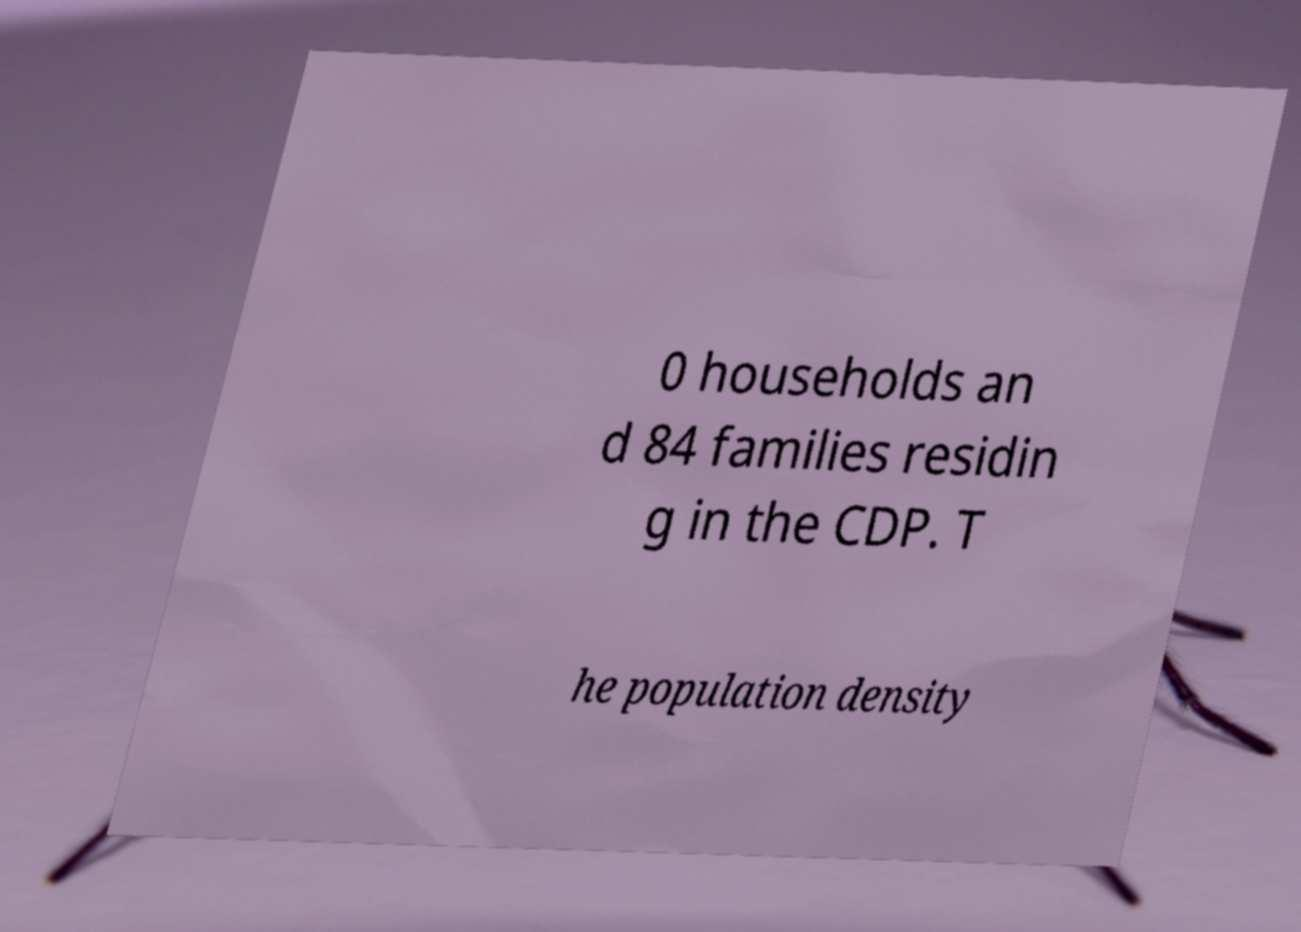Could you assist in decoding the text presented in this image and type it out clearly? 0 households an d 84 families residin g in the CDP. T he population density 